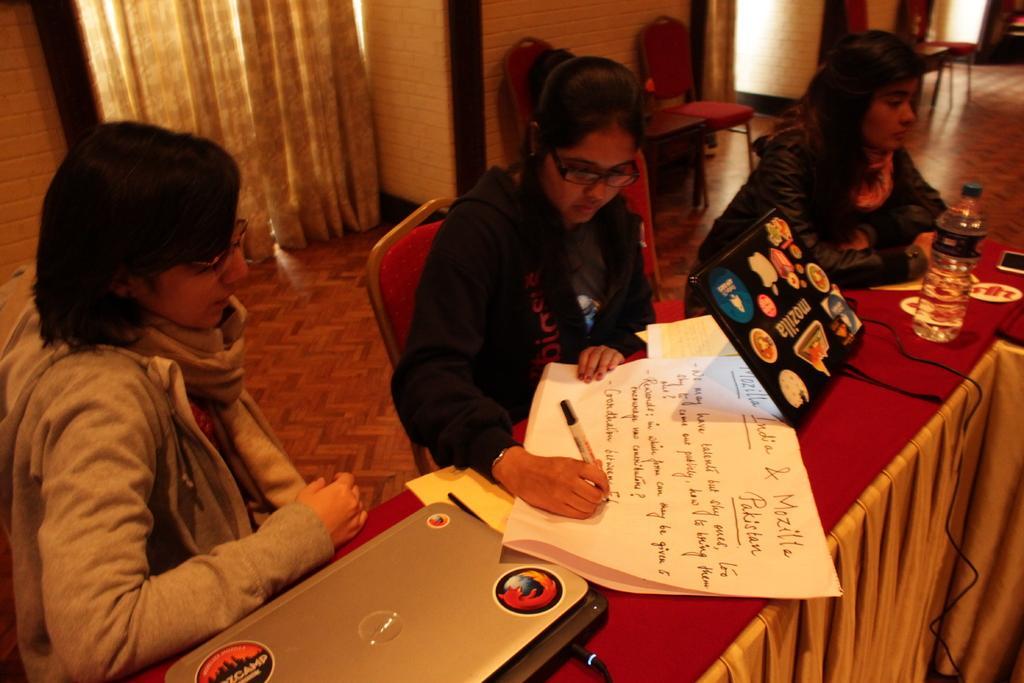Could you give a brief overview of what you see in this image? In this image on the right, there is a table on that there are papers, laptops, pens, cables, bottle, mobile and cloth. On the left there is a woman, she wears a jacket, she is sitting. In the middle there is a woman, she wears a jacket, she is sitting. On the right there is a woman, she wears a jacket, she is sitting. At the top there are curtains, chairs, wall. 